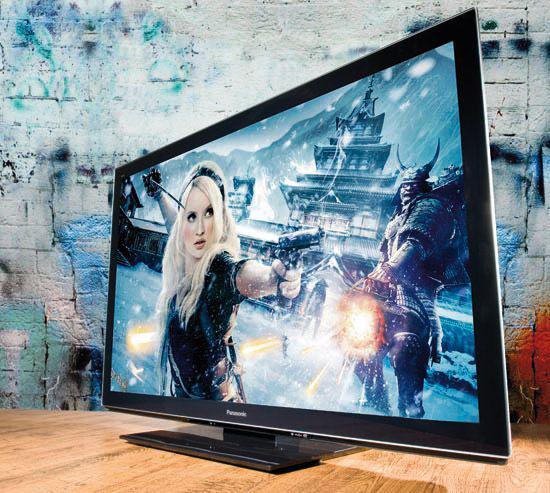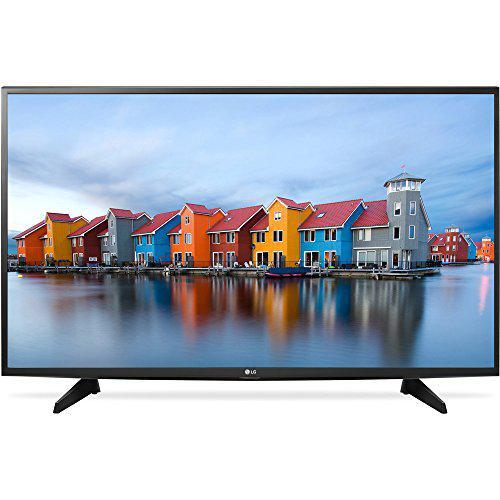The first image is the image on the left, the second image is the image on the right. Assess this claim about the two images: "A TV shows picture quality by displaying a picture of pink flowers beneath sky with clouds.". Correct or not? Answer yes or no. No. The first image is the image on the left, the second image is the image on the right. Examine the images to the left and right. Is the description "One of the TVs has flowers on the display." accurate? Answer yes or no. No. 